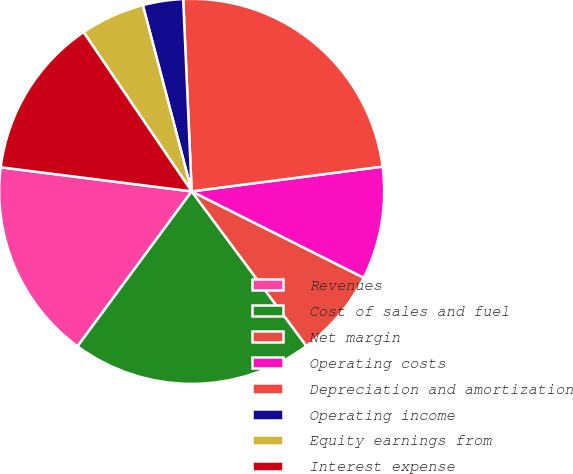Convert chart. <chart><loc_0><loc_0><loc_500><loc_500><pie_chart><fcel>Revenues<fcel>Cost of sales and fuel<fcel>Net margin<fcel>Operating costs<fcel>Depreciation and amortization<fcel>Operating income<fcel>Equity earnings from<fcel>Interest expense<nl><fcel>16.89%<fcel>20.27%<fcel>7.43%<fcel>9.46%<fcel>23.65%<fcel>3.38%<fcel>5.41%<fcel>13.51%<nl></chart> 